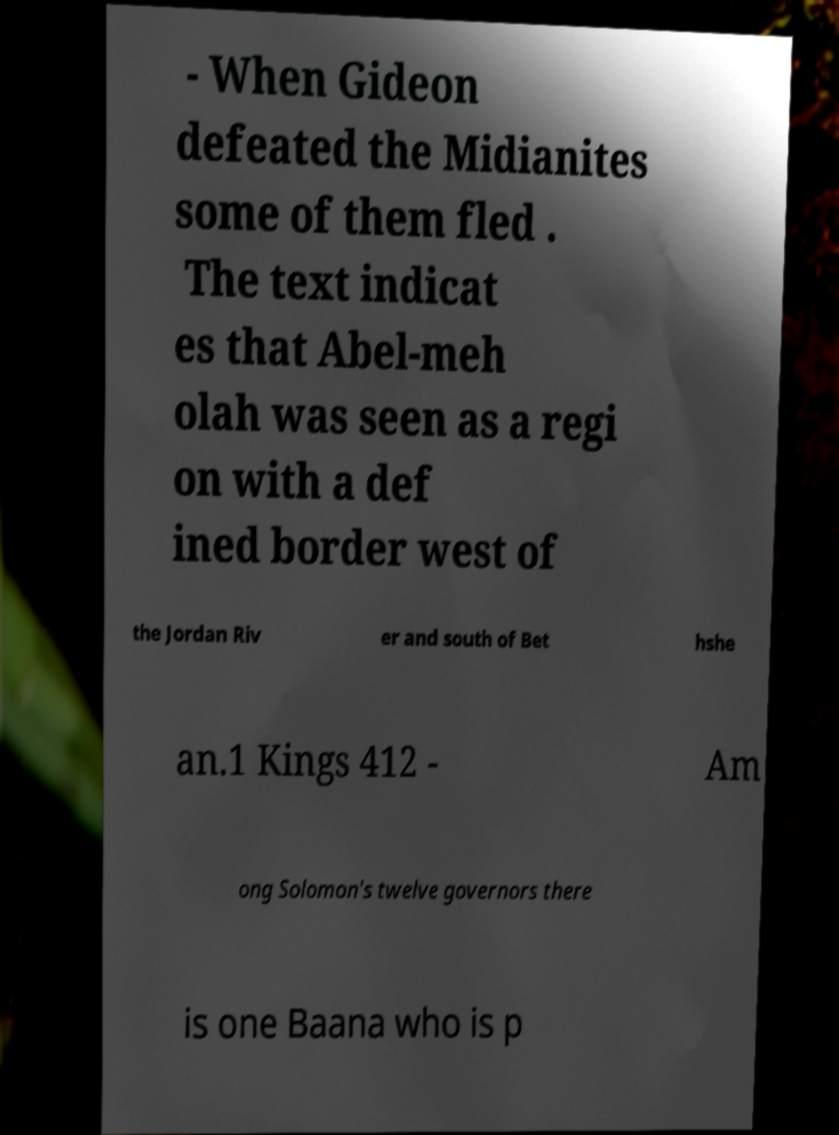For documentation purposes, I need the text within this image transcribed. Could you provide that? - When Gideon defeated the Midianites some of them fled . The text indicat es that Abel-meh olah was seen as a regi on with a def ined border west of the Jordan Riv er and south of Bet hshe an.1 Kings 412 - Am ong Solomon's twelve governors there is one Baana who is p 